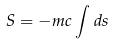Convert formula to latex. <formula><loc_0><loc_0><loc_500><loc_500>S = - m c \int d s</formula> 